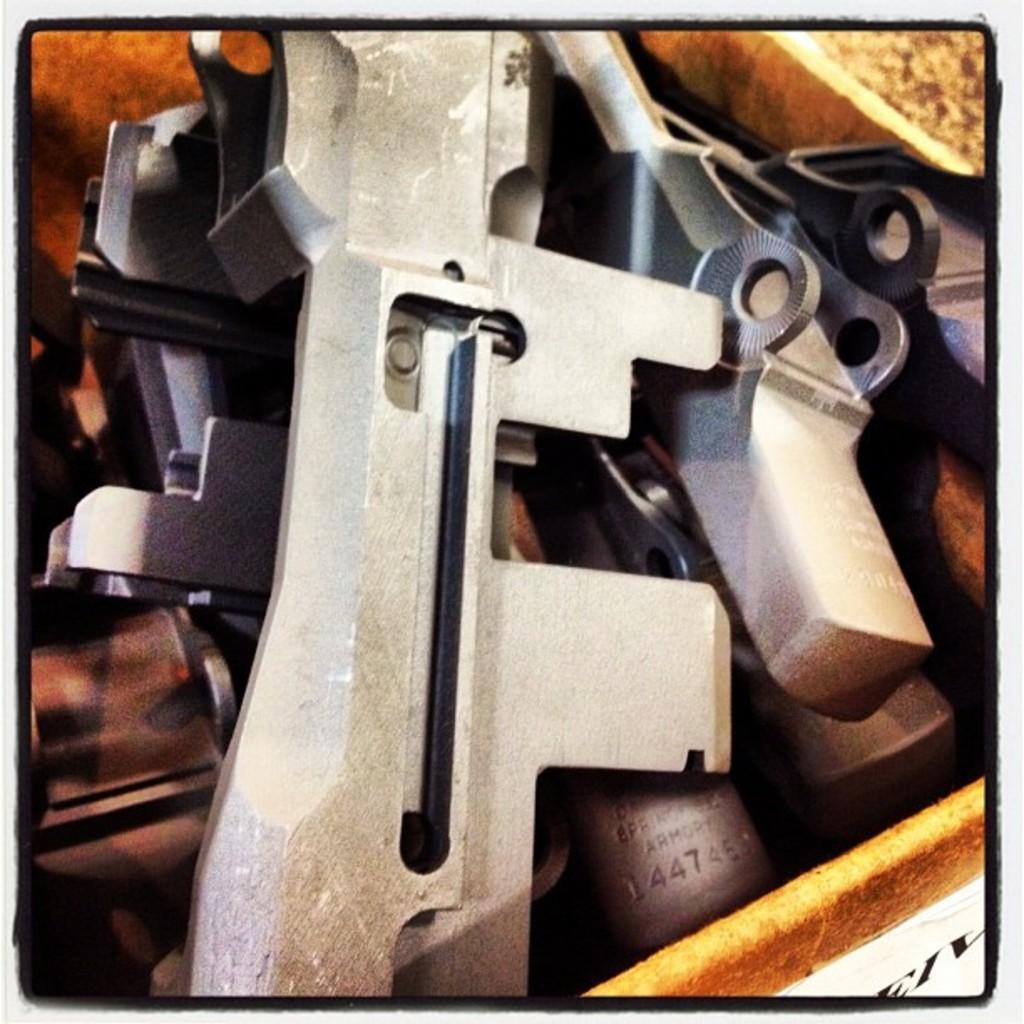In one or two sentences, can you explain what this image depicts? In this image there are objects, there are objects truncated towards the bottom of the image, there are objects truncated right the bottom of the image, there are objects truncated towards the left of the image, there are objects truncated towards the top of the image, there is text. 